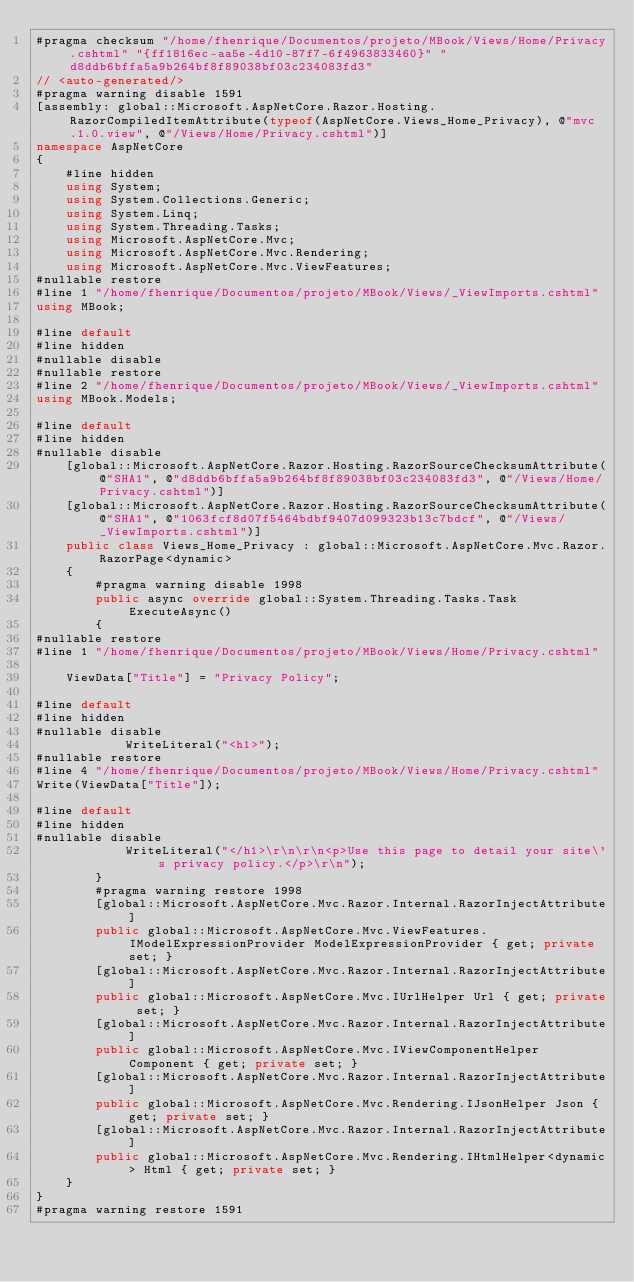Convert code to text. <code><loc_0><loc_0><loc_500><loc_500><_C#_>#pragma checksum "/home/fhenrique/Documentos/projeto/MBook/Views/Home/Privacy.cshtml" "{ff1816ec-aa5e-4d10-87f7-6f4963833460}" "d8ddb6bffa5a9b264bf8f89038bf03c234083fd3"
// <auto-generated/>
#pragma warning disable 1591
[assembly: global::Microsoft.AspNetCore.Razor.Hosting.RazorCompiledItemAttribute(typeof(AspNetCore.Views_Home_Privacy), @"mvc.1.0.view", @"/Views/Home/Privacy.cshtml")]
namespace AspNetCore
{
    #line hidden
    using System;
    using System.Collections.Generic;
    using System.Linq;
    using System.Threading.Tasks;
    using Microsoft.AspNetCore.Mvc;
    using Microsoft.AspNetCore.Mvc.Rendering;
    using Microsoft.AspNetCore.Mvc.ViewFeatures;
#nullable restore
#line 1 "/home/fhenrique/Documentos/projeto/MBook/Views/_ViewImports.cshtml"
using MBook;

#line default
#line hidden
#nullable disable
#nullable restore
#line 2 "/home/fhenrique/Documentos/projeto/MBook/Views/_ViewImports.cshtml"
using MBook.Models;

#line default
#line hidden
#nullable disable
    [global::Microsoft.AspNetCore.Razor.Hosting.RazorSourceChecksumAttribute(@"SHA1", @"d8ddb6bffa5a9b264bf8f89038bf03c234083fd3", @"/Views/Home/Privacy.cshtml")]
    [global::Microsoft.AspNetCore.Razor.Hosting.RazorSourceChecksumAttribute(@"SHA1", @"1063fcf8d07f5464bdbf9407d099323b13c7bdcf", @"/Views/_ViewImports.cshtml")]
    public class Views_Home_Privacy : global::Microsoft.AspNetCore.Mvc.Razor.RazorPage<dynamic>
    {
        #pragma warning disable 1998
        public async override global::System.Threading.Tasks.Task ExecuteAsync()
        {
#nullable restore
#line 1 "/home/fhenrique/Documentos/projeto/MBook/Views/Home/Privacy.cshtml"
  
    ViewData["Title"] = "Privacy Policy";

#line default
#line hidden
#nullable disable
            WriteLiteral("<h1>");
#nullable restore
#line 4 "/home/fhenrique/Documentos/projeto/MBook/Views/Home/Privacy.cshtml"
Write(ViewData["Title"]);

#line default
#line hidden
#nullable disable
            WriteLiteral("</h1>\r\n\r\n<p>Use this page to detail your site\'s privacy policy.</p>\r\n");
        }
        #pragma warning restore 1998
        [global::Microsoft.AspNetCore.Mvc.Razor.Internal.RazorInjectAttribute]
        public global::Microsoft.AspNetCore.Mvc.ViewFeatures.IModelExpressionProvider ModelExpressionProvider { get; private set; }
        [global::Microsoft.AspNetCore.Mvc.Razor.Internal.RazorInjectAttribute]
        public global::Microsoft.AspNetCore.Mvc.IUrlHelper Url { get; private set; }
        [global::Microsoft.AspNetCore.Mvc.Razor.Internal.RazorInjectAttribute]
        public global::Microsoft.AspNetCore.Mvc.IViewComponentHelper Component { get; private set; }
        [global::Microsoft.AspNetCore.Mvc.Razor.Internal.RazorInjectAttribute]
        public global::Microsoft.AspNetCore.Mvc.Rendering.IJsonHelper Json { get; private set; }
        [global::Microsoft.AspNetCore.Mvc.Razor.Internal.RazorInjectAttribute]
        public global::Microsoft.AspNetCore.Mvc.Rendering.IHtmlHelper<dynamic> Html { get; private set; }
    }
}
#pragma warning restore 1591
</code> 